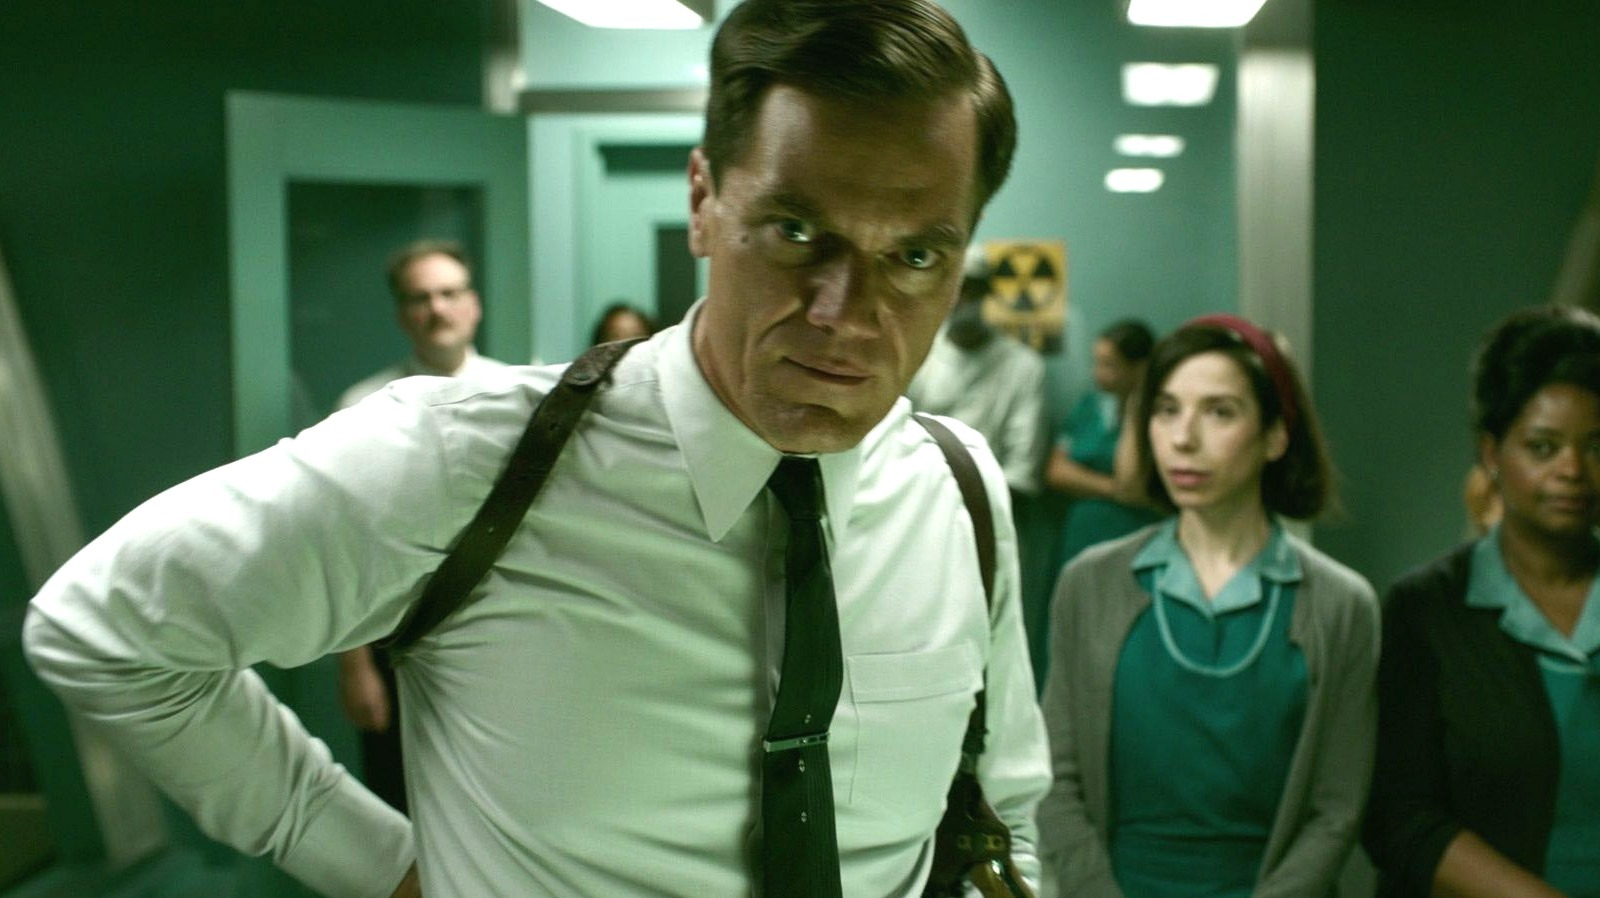What might the man in the white shirt be thinking at this moment? The man in the white shirt appears to be deeply concerned or possibly troubled by the current circumstances in the hospital. His stern expression and focused posture might indicate he is preparing to make a critical decision or deal with a challenging situation. 